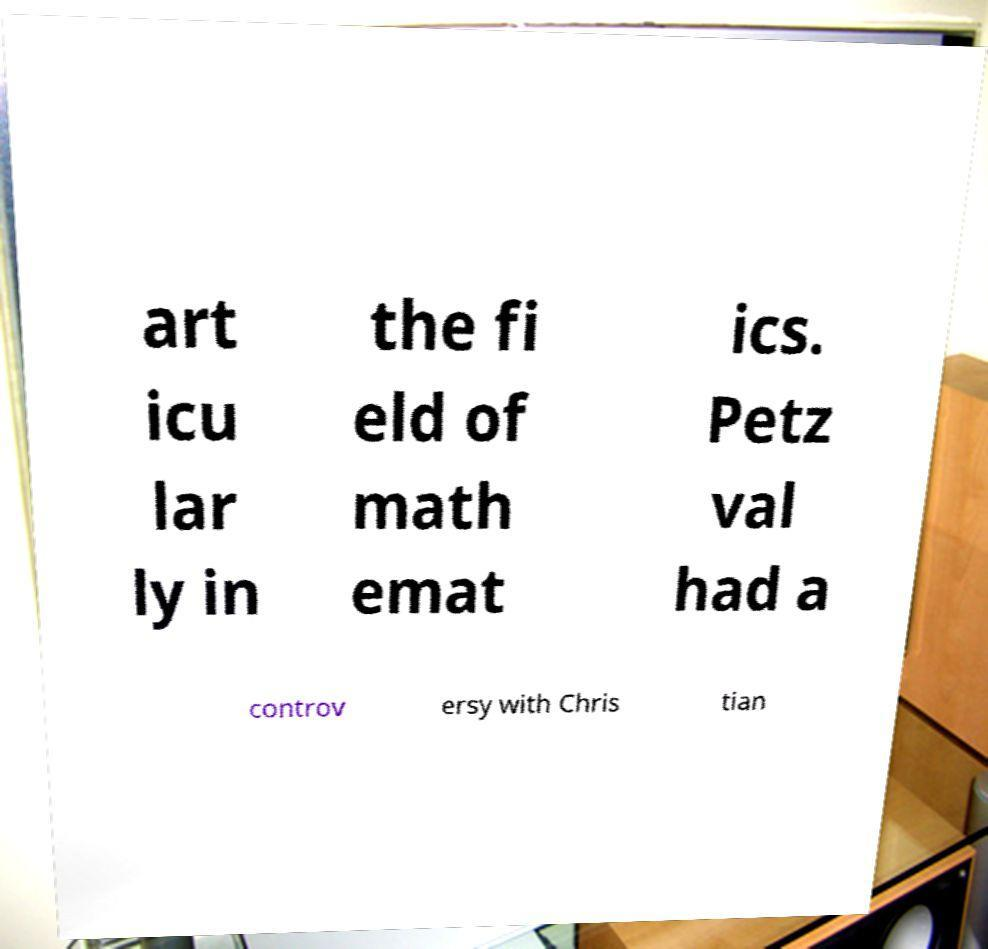Could you extract and type out the text from this image? art icu lar ly in the fi eld of math emat ics. Petz val had a controv ersy with Chris tian 